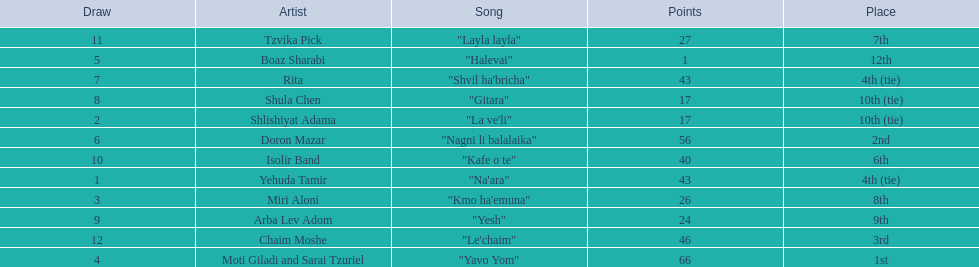What is the place of the contestant who received only 1 point? 12th. What is the name of the artist listed in the previous question? Boaz Sharabi. 